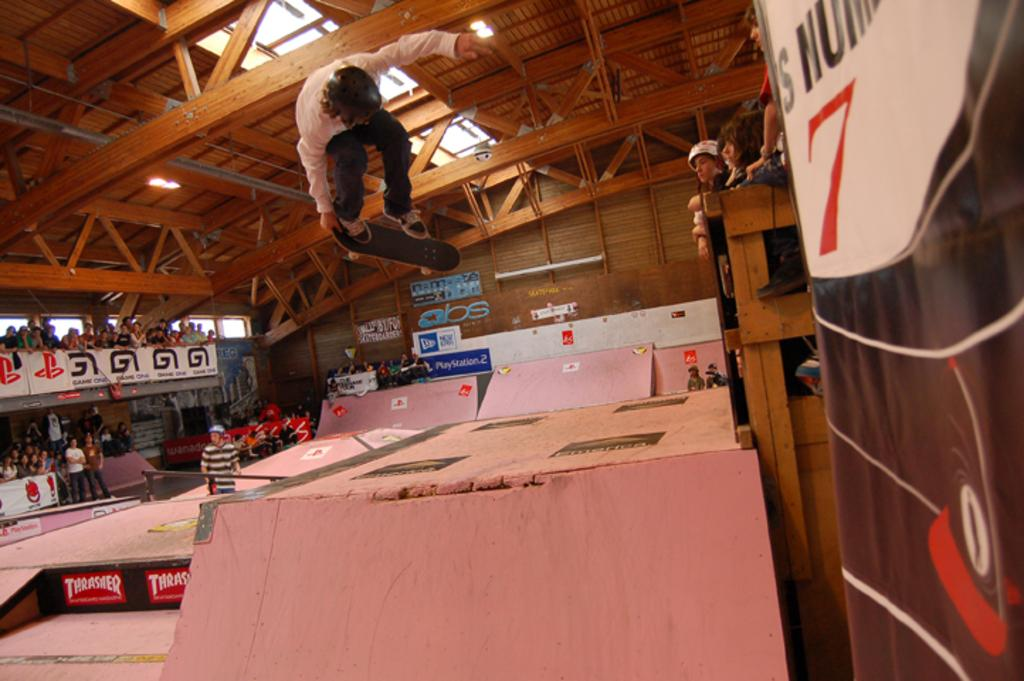What is the main activity being performed in the image? There is a person skating in the image. Are there any spectators in the image? Yes, there are people in the audience watching the skater. What can be seen attached to the ceiling in the image? There are lights attached to the ceiling in the image. What decorative elements are present in the image? There are banners present in the image. What type of bread is being used as a prop in the image? There is no bread present in the image. 